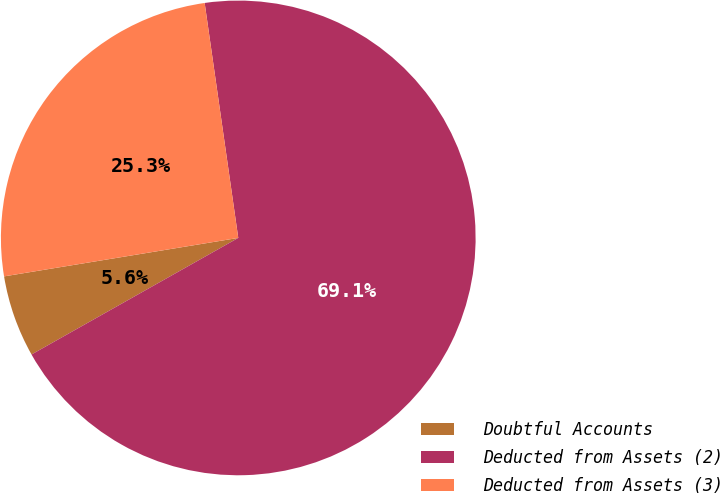<chart> <loc_0><loc_0><loc_500><loc_500><pie_chart><fcel>Doubtful Accounts<fcel>Deducted from Assets (2)<fcel>Deducted from Assets (3)<nl><fcel>5.58%<fcel>69.09%<fcel>25.33%<nl></chart> 